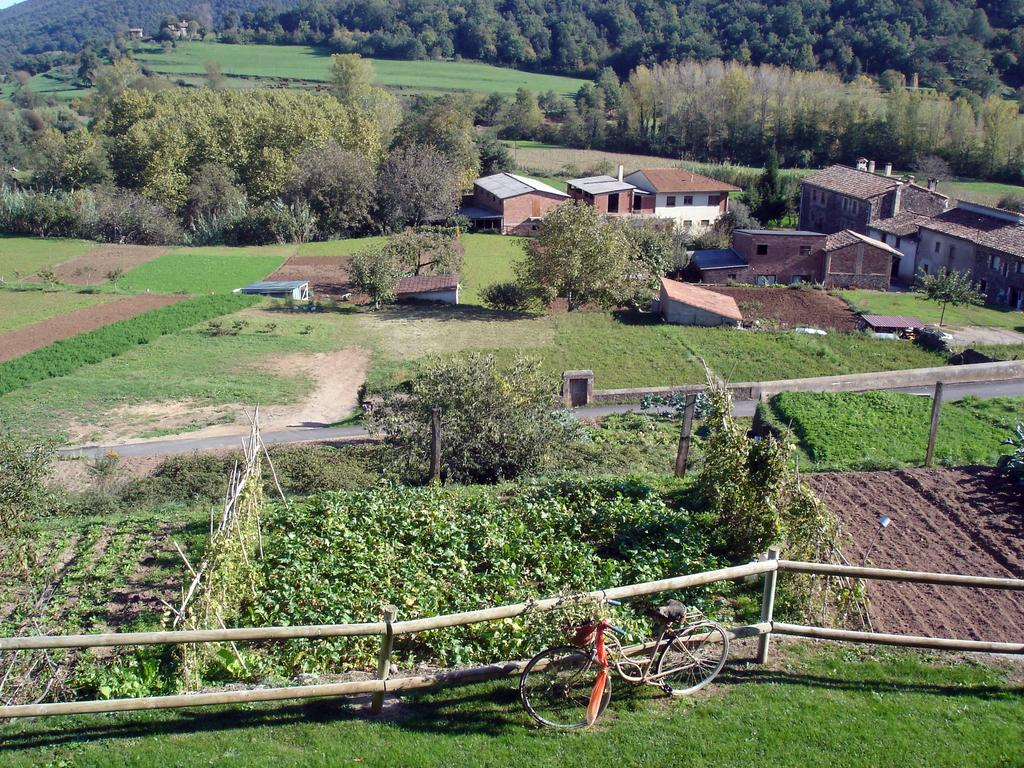What is the main object in the image? There is a bicycle in the image. What type of fencing can be seen in the image? There is wooden fencing in the image. What type of landscape is visible in the image? There are fields visible in the image. What type of structures can be seen in the image? There are houses in the image. What type of vegetation is visible in the image? There are trees in the image. What time of day is it in the image, and what type of ray is visible? The time of day is not specified in the image, and there is no mention of any type of ray. What type of glue is being used to hold the bicycle together in the image? There is no indication in the image that any glue is being used to hold the bicycle together. 